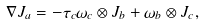<formula> <loc_0><loc_0><loc_500><loc_500>\nabla J _ { a } = - \tau _ { c } \omega _ { c } \otimes J _ { b } + \omega _ { b } \otimes J _ { c } ,</formula> 